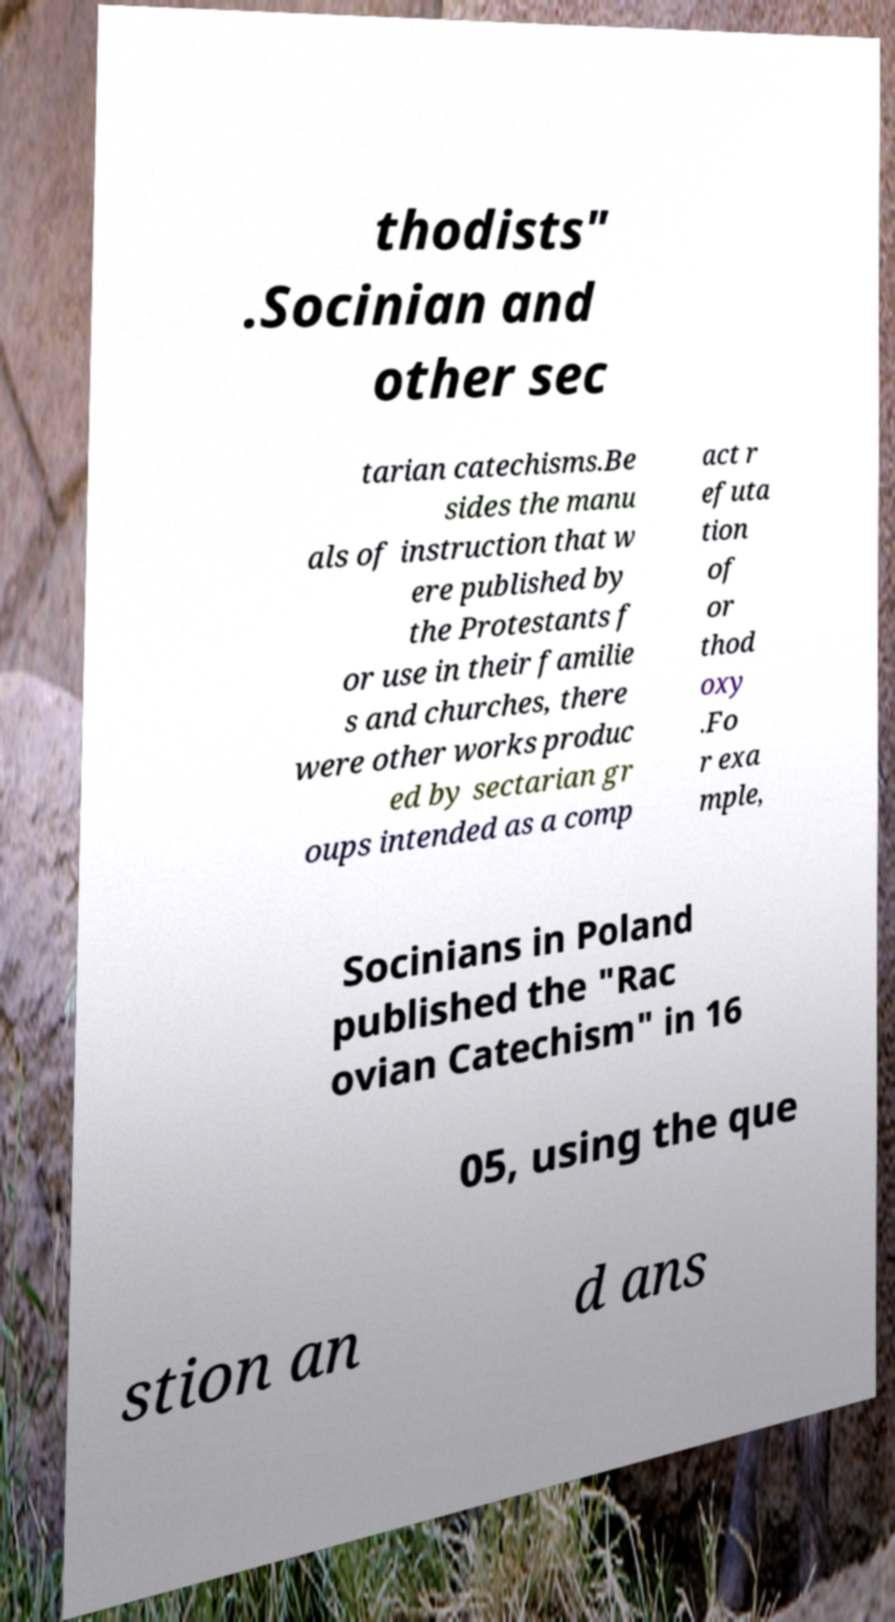Can you accurately transcribe the text from the provided image for me? thodists" .Socinian and other sec tarian catechisms.Be sides the manu als of instruction that w ere published by the Protestants f or use in their familie s and churches, there were other works produc ed by sectarian gr oups intended as a comp act r efuta tion of or thod oxy .Fo r exa mple, Socinians in Poland published the "Rac ovian Catechism" in 16 05, using the que stion an d ans 